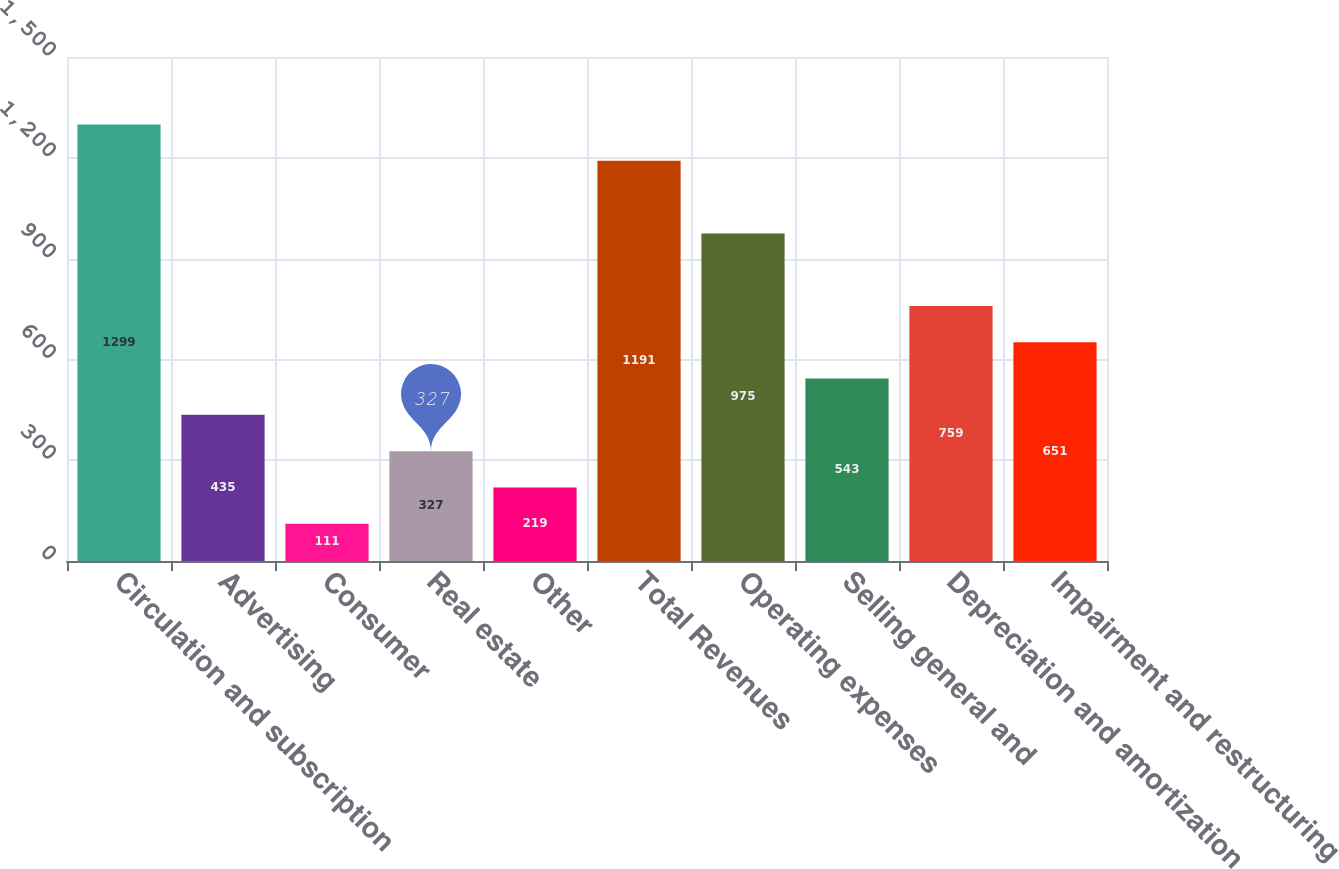<chart> <loc_0><loc_0><loc_500><loc_500><bar_chart><fcel>Circulation and subscription<fcel>Advertising<fcel>Consumer<fcel>Real estate<fcel>Other<fcel>Total Revenues<fcel>Operating expenses<fcel>Selling general and<fcel>Depreciation and amortization<fcel>Impairment and restructuring<nl><fcel>1299<fcel>435<fcel>111<fcel>327<fcel>219<fcel>1191<fcel>975<fcel>543<fcel>759<fcel>651<nl></chart> 